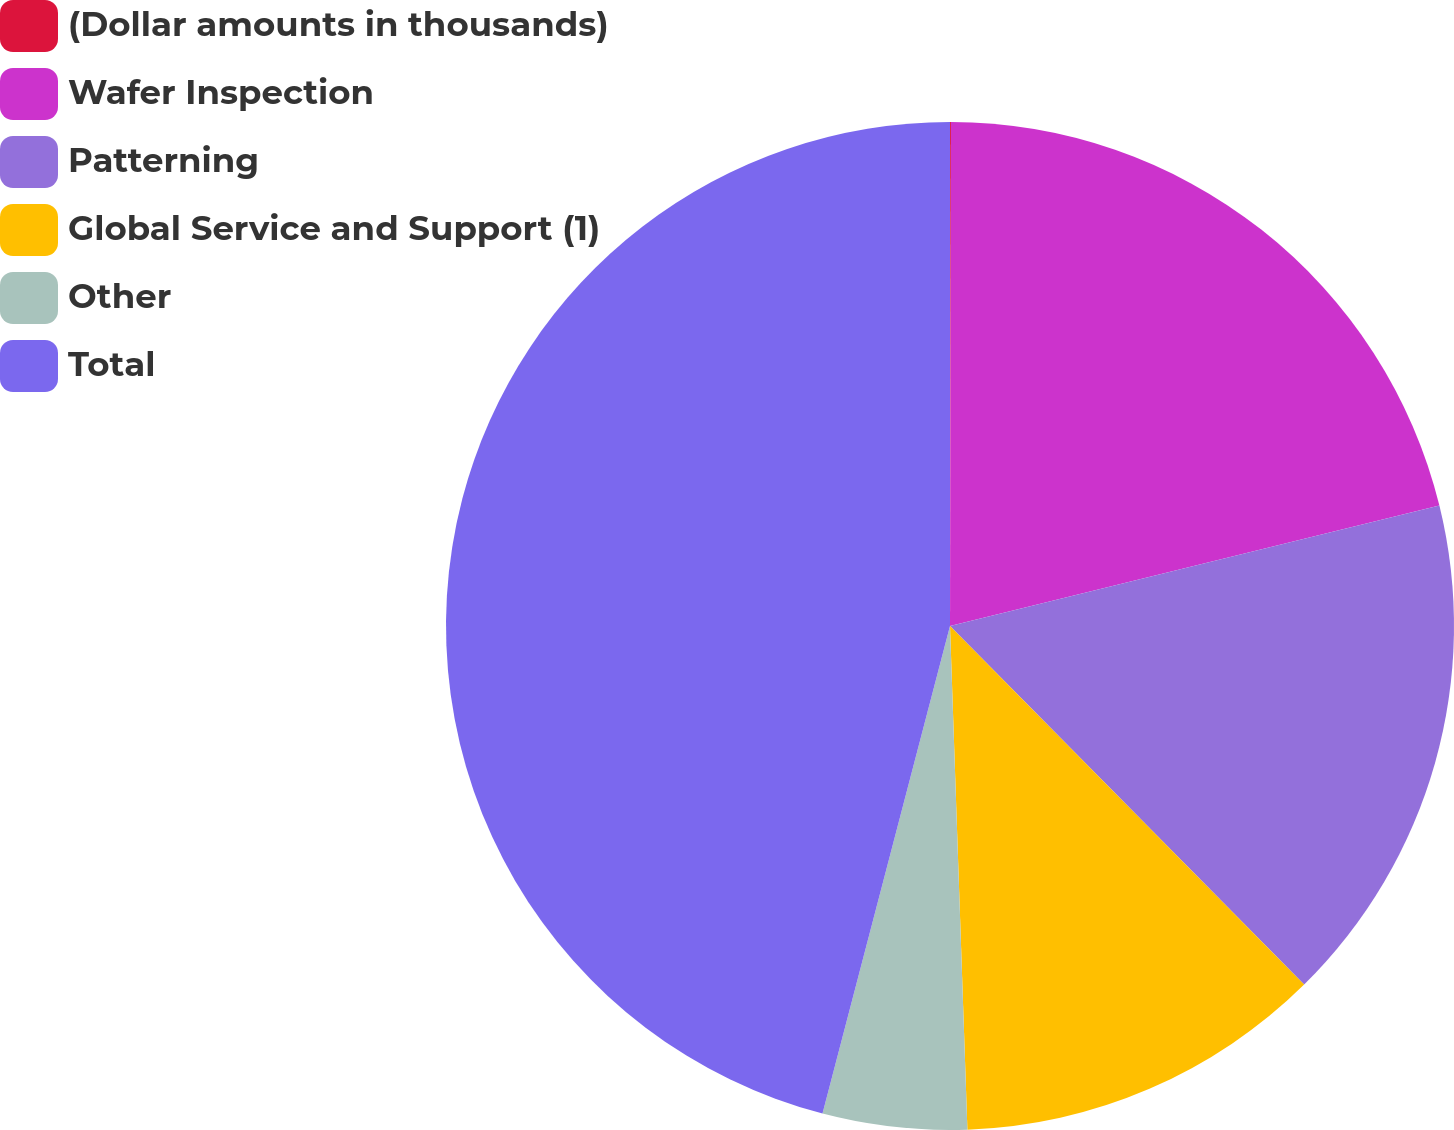Convert chart to OTSL. <chart><loc_0><loc_0><loc_500><loc_500><pie_chart><fcel>(Dollar amounts in thousands)<fcel>Wafer Inspection<fcel>Patterning<fcel>Global Service and Support (1)<fcel>Other<fcel>Total<nl><fcel>0.03%<fcel>21.13%<fcel>16.44%<fcel>11.85%<fcel>4.62%<fcel>45.93%<nl></chart> 